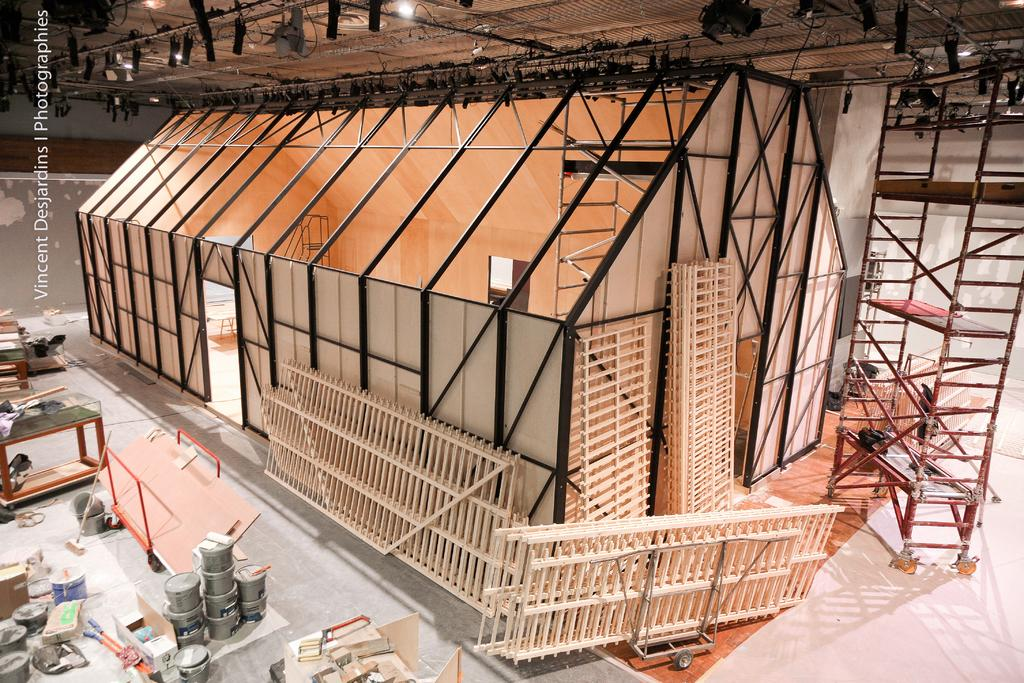What type of space is depicted in the image? There is a room in the image. What can be seen within the room? There are metal frames visible in the image. What is located at the top of the image? There are lights visible at the top of the image. Can you describe any other objects present in the room? There are other objects present in the image, but their specific details are not mentioned in the provided facts. How many toes can be seen on the cast in the image? There is no cast or toes present in the image. What type of activity is taking place in the room in the image? The provided facts do not mention any specific activity taking place in the room, so it cannot be determined from the image. 